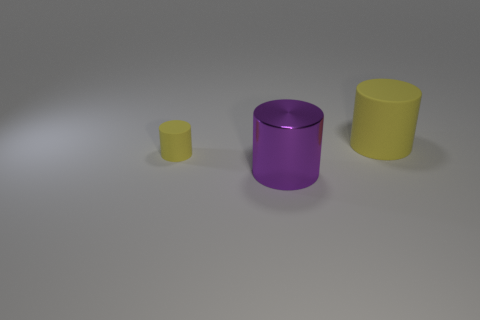Add 3 large purple matte objects. How many objects exist? 6 Subtract 0 green cylinders. How many objects are left? 3 Subtract all big cyan metal cylinders. Subtract all rubber cylinders. How many objects are left? 1 Add 3 rubber cylinders. How many rubber cylinders are left? 5 Add 1 yellow matte cylinders. How many yellow matte cylinders exist? 3 